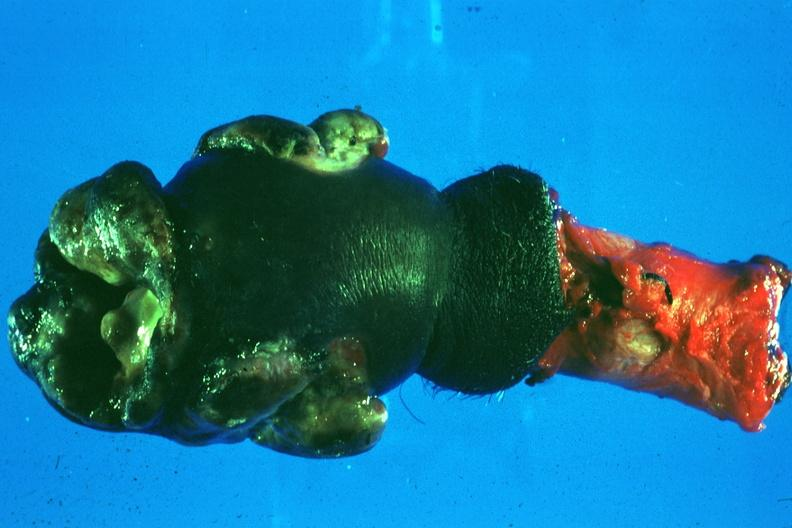s squamous cell carcinoma present?
Answer the question using a single word or phrase. Yes 